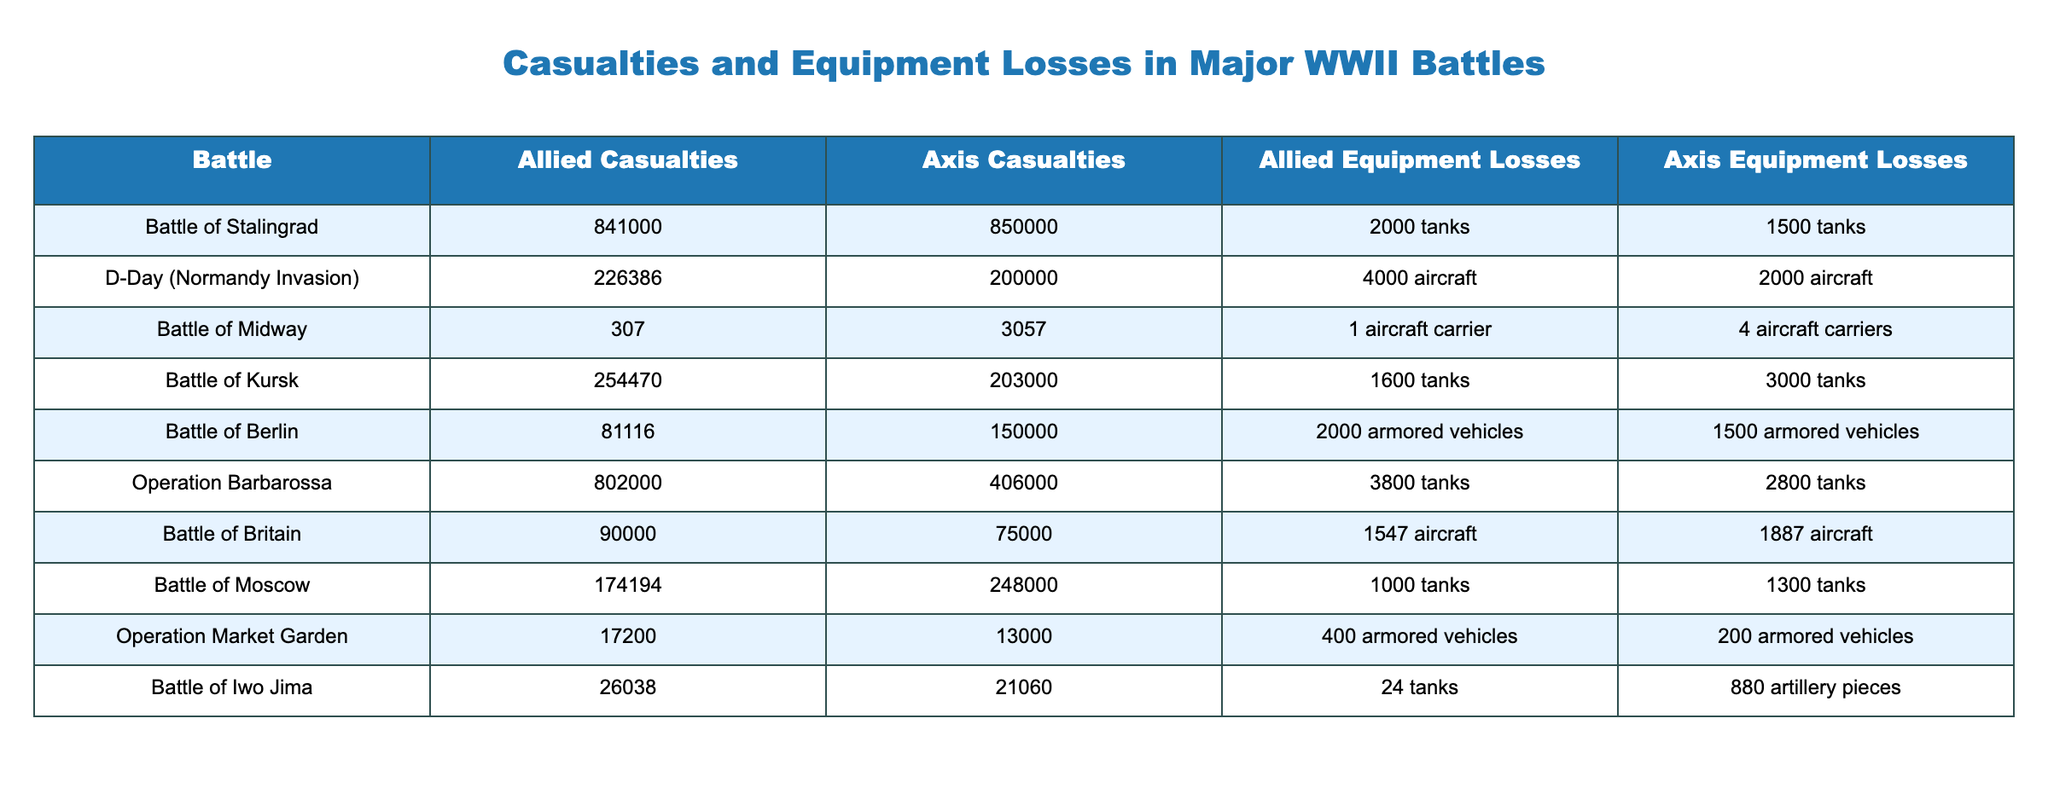What were the total Allied casualties in the Battle of Stalingrad? The table shows that the Allied casualties for the Battle of Stalingrad are listed as 841,000.
Answer: 841,000 What was the Axis equipment loss in the Battle of Normandy? The table indicates that the equipment losses for the Axis in the D-Day (Normandy Invasion) are noted as 2,000 aircraft.
Answer: 2,000 aircraft Which battle resulted in the highest combined casualties (Allied and Axis)? To determine the battle with the highest combined casualties, sum the Allied and Axis casualties for each battle. The Battle of Stalingrad has 841,000 + 850,000 = 1,691,000, which is the highest total.
Answer: Battle of Stalingrad Is it true that the Allied equipment losses in the Battle of Kursk were greater than the Axis equipment losses? From the table, the Allied equipment losses in the Battle of Kursk are 1,600 tanks, while the Axis equipment losses are 3,000 tanks. Thus, this statement is false.
Answer: No What is the average number of Allied casualties across all listed battles? To find the average, we sum the Allied casualties: (841,000 + 226,386 + 307 + 254,470 + 81,116 + 802,000 + 90,000 + 174,194 + 17,200 + 26,038) = 2,213,911. Then, divide by the number of battles (10) to get 221,391.1.
Answer: 221,391.1 What was the difference in Allied equipment losses between the Battle of Midway and Operation Barbarossa? The Allied equipment losses for the Battle of Midway are 1 aircraft carrier (converted to a numerical value of 1) while for Operation Barbarossa, it is 3,800 tanks. The difference between them is 3,800 - 1 = 3,799.
Answer: 3,799 Did the Battle of Britain have more Axis casualties than the Battle of Iwo Jima? From the table, the Axis casualties for the Battle of Britain are 75,000, while for Iwo Jima they are 21,060. Since 75,000 > 21,060, the statement is true.
Answer: Yes What was the total amount of equipment lost by the Allied forces in the Battle of Berlin and Operation Market Garden combined? The Allied equipment losses in the Battle of Berlin are 2,000 armored vehicles and in Operation Market Garden are 400 armored vehicles. The total is 2,000 + 400 = 2,400 armored vehicles.
Answer: 2,400 armored vehicles 